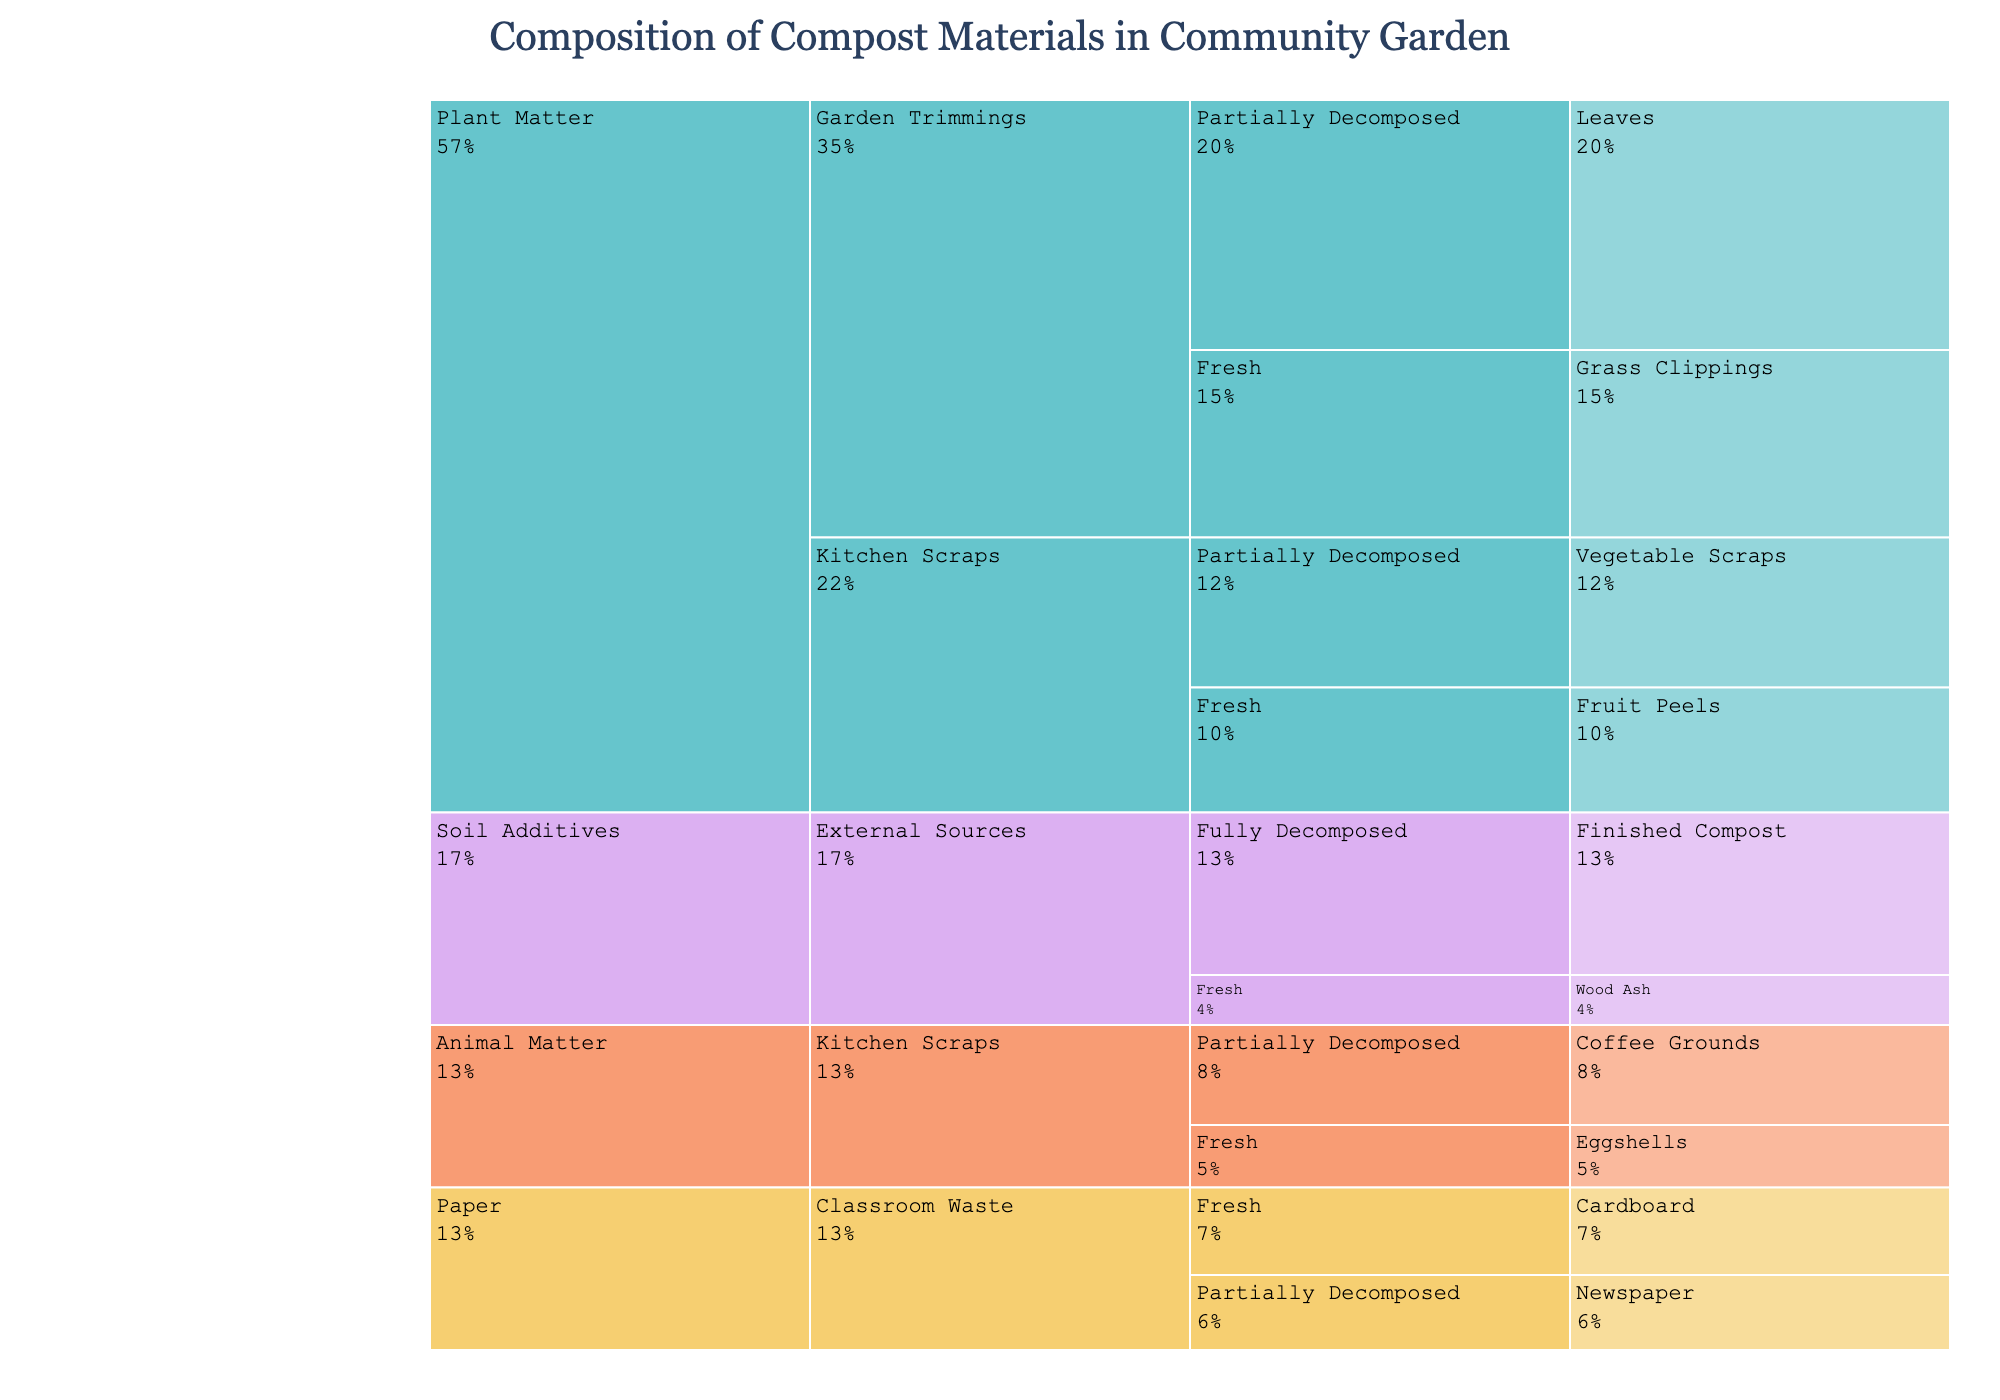What is the title of the icicle chart? The title is typically displayed at the top center of the chart, and here it reads 'Composition of Compost Materials in Community Garden' in a larger and stylized font.
Answer: Composition of Compost Materials in Community Garden Which category in the chart has the highest percentage in fresh decomposition stage? Locate the category sections labeled 'Plant Matter', 'Animal Matter', 'Paper', and 'Soil Additives'. Then check under the 'Fresh' decomposition stage within each category to compare percentages. 'Plant Matter' under 'Garden Trimmings' has 15% for Grass Clippings, which is the highest.
Answer: Plant Matter How much percentage of compost materials is contributed by Kitchen Scraps in total? Identify all entries under the 'Kitchen Scraps' source. Sum the percentages for 'Fruit Peels' (10%), 'Vegetable Scraps' (12%), 'Eggshells' (5%), and 'Coffee Grounds' (8%). Adding them gives 35%.
Answer: 35% Which material has the lowest percentage in the chart? Browse through all segments of the icicle chart and identify the one with the smallest percentage. 'Wood Ash' under 'Soil Additives' and 'External Sources' at 4% is the smallest percentage.
Answer: Wood Ash Compare the percentage of Grass Clippings to Finished Compost. Which one is higher and by how much? Look at the percentages for 'Grass Clippings' under 'Garden Trimmings' in the 'Fresh' section (15%) and 'Finished Compost' under 'External Sources' in the 'Fully Decomposed' section (13%). Subtract 13% from 15% to find the difference, which is 2%.
Answer: Grass Clippings is higher by 2% How many categories contribute partially decomposed materials? Look for all sections with 'Partially Decomposed' and count how many different categories appear there. 'Plant Matter' (Leaves and Vegetable Scraps), 'Animal Matter' (Coffee Grounds), and 'Paper' (Newspaper) are three categories.
Answer: 3 Which source has a wider variety of materials, Garden Trimmings or Kitchen Scraps? Examine the individual materials listed under 'Garden Trimmings' and 'Kitchen Scraps'. 'Garden Trimmings' has Grass Clippings and Leaves (2 materials), while 'Kitchen Scraps' has Fruit Peels, Vegetable Scraps, Eggshells, and Coffee Grounds (4 materials).
Answer: Kitchen Scraps What is the combined percentage of Paper materials classified as Fresh and Partially Decomposed? Find the percentages for 'Cardboard' (7%) and 'Newspaper' (6%) under 'Paper' category. Add them together; so, 7% + 6% = 13%.
Answer: 13% What decomposition stage has the smallest combined percentage for Plant Matter from Garden Trimmings? Identify the respective percentages under 'Plant Matter' from 'Garden Trimmings' and sum them per decomposition stage. 'Fresh' has Grass Clippings (15%) and 'Partially Decomposed' has Leaves (20%). 'Fresh' total is 15% which is smaller than 20%.
Answer: Fresh Which category contributes finished compost material, and what's its percentage? Check the full hierarchy for 'Finished Compost' material and observe the top category it falls under. 'Soil Additives' from 'External Sources' is the category, with 13%.
Answer: Soil Additives, 13% 